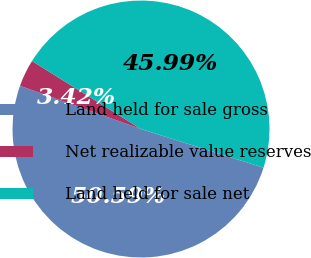<chart> <loc_0><loc_0><loc_500><loc_500><pie_chart><fcel>Land held for sale gross<fcel>Net realizable value reserves<fcel>Land held for sale net<nl><fcel>50.59%<fcel>3.42%<fcel>45.99%<nl></chart> 